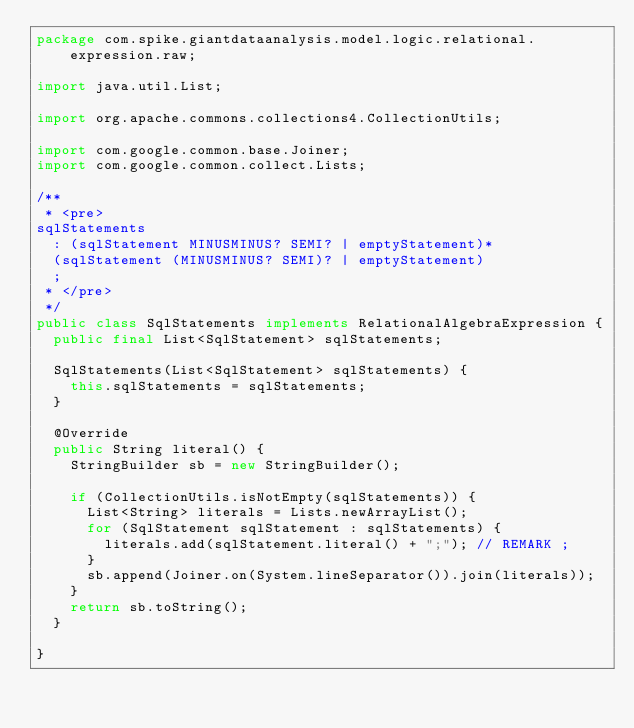Convert code to text. <code><loc_0><loc_0><loc_500><loc_500><_Java_>package com.spike.giantdataanalysis.model.logic.relational.expression.raw;

import java.util.List;

import org.apache.commons.collections4.CollectionUtils;

import com.google.common.base.Joiner;
import com.google.common.collect.Lists;

/**
 * <pre>
sqlStatements
  : (sqlStatement MINUSMINUS? SEMI? | emptyStatement)*
  (sqlStatement (MINUSMINUS? SEMI)? | emptyStatement)
  ;
 * </pre>
 */
public class SqlStatements implements RelationalAlgebraExpression {
  public final List<SqlStatement> sqlStatements;

  SqlStatements(List<SqlStatement> sqlStatements) {
    this.sqlStatements = sqlStatements;
  }

  @Override
  public String literal() {
    StringBuilder sb = new StringBuilder();

    if (CollectionUtils.isNotEmpty(sqlStatements)) {
      List<String> literals = Lists.newArrayList();
      for (SqlStatement sqlStatement : sqlStatements) {
        literals.add(sqlStatement.literal() + ";"); // REMARK ;
      }
      sb.append(Joiner.on(System.lineSeparator()).join(literals));
    }
    return sb.toString();
  }

}</code> 